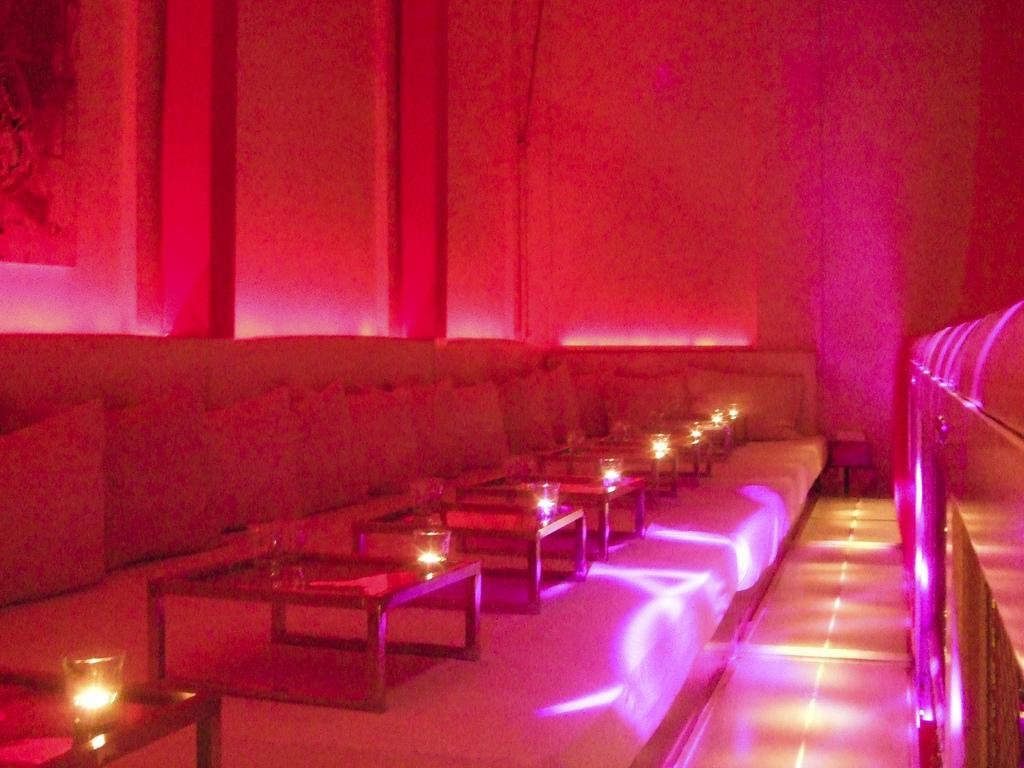In one or two sentences, can you explain what this image depicts? On these beds there are tables with glasses and pillows.  